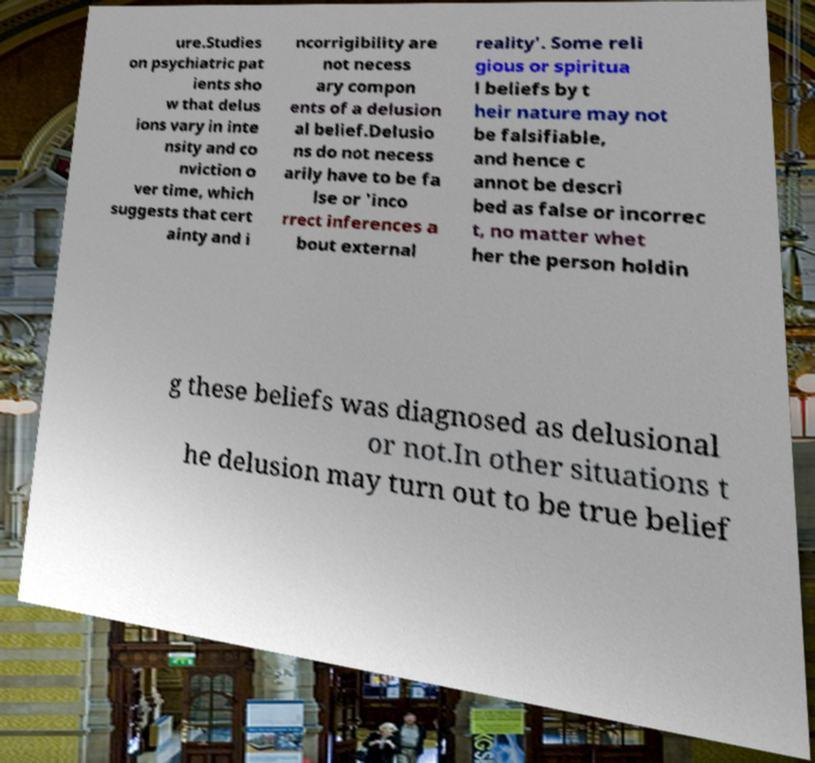For documentation purposes, I need the text within this image transcribed. Could you provide that? ure.Studies on psychiatric pat ients sho w that delus ions vary in inte nsity and co nviction o ver time, which suggests that cert ainty and i ncorrigibility are not necess ary compon ents of a delusion al belief.Delusio ns do not necess arily have to be fa lse or 'inco rrect inferences a bout external reality'. Some reli gious or spiritua l beliefs by t heir nature may not be falsifiable, and hence c annot be descri bed as false or incorrec t, no matter whet her the person holdin g these beliefs was diagnosed as delusional or not.In other situations t he delusion may turn out to be true belief 